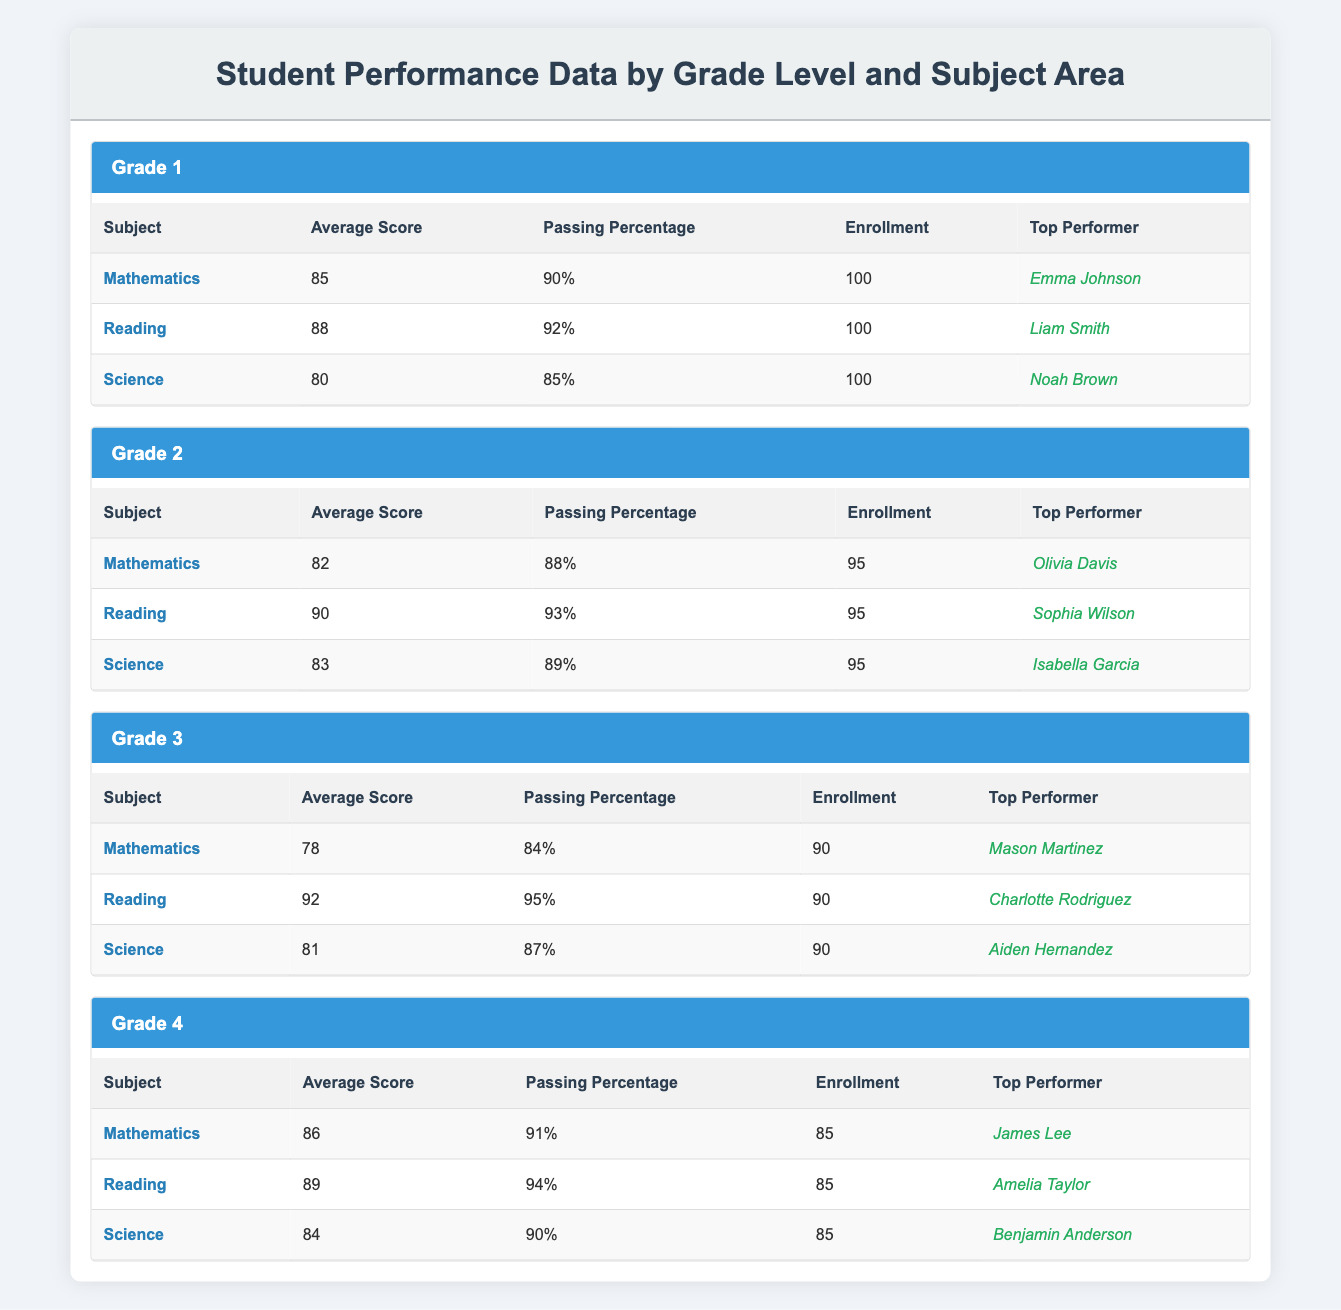What is the top performer in Mathematics for Grade 1? The table shows that the top performer in Mathematics for Grade 1 is Emma Johnson, as listed in the corresponding row.
Answer: Emma Johnson What is the average score in Reading for Grade 3? The table indicates that the average score in Reading for Grade 3 is 92, found in the respective row under the Reading column for Grade 3.
Answer: 92 Which grade has the highest average score in Science? The average scores for Science across grades are: Grade 1: 80, Grade 2: 83, Grade 3: 81, and Grade 4: 84. Comparing these values, Grade 4 has the highest average score, which is 84.
Answer: Grade 4 What is the overall passing percentage for Mathematics across all grades? The passing percentages for Mathematics are: Grade 1: 90%, Grade 2: 88%, Grade 3: 84%, and Grade 4: 91%. To find the overall passing percentage, we sum these percentages: 90 + 88 + 84 + 91 = 353, and then divide by the number of grades (4), giving us an average of 353/4 = 88.25%.
Answer: 88.25% Is there any subject where Grade 2 has a higher average score than Grade 1? In the table, the average scores for Grade 1 are Mathematics: 85, Reading: 88, and Science: 80. For Grade 2, the scores are Mathematics: 82, Reading: 90, and Science: 83. Comparing these, Grade 2 has a higher average score in Reading (90 > 88), but lower scores in Mathematics and Science. Thus, yes, Reading is the subject where Grade 2's score is higher.
Answer: Yes What is the average enrollment across all grades for Reading? The enrollment for Reading is: Grade 1: 100, Grade 2: 95, Grade 3: 90, and Grade 4: 85. To find the average, we sum these values: 100 + 95 + 90 + 85 = 370, and divide by 4 for the average, which gives us 370/4 = 92.5.
Answer: 92.5 What is the difference in passing percentages for Science between Grade 3 and Grade 4? The passing percentage for Science in Grade 3 is 87% and in Grade 4 it is 90%. To find the difference, we subtract the smaller percentage from the larger one: 90 - 87 = 3.
Answer: 3 Which subject has the lowest passing percentage in Grade 1? The passing percentages for Grade 1 subjects are Mathematics: 90%, Reading: 92%, and Science: 85%. The lowest is Science with a passing percentage of 85.
Answer: Science What is the top-performing grade in Reading based on average score? The average scores for Reading are: Grade 1: 88, Grade 2: 90, Grade 3: 92, and Grade 4: 89. The highest score is for Grade 3 at 92.
Answer: Grade 3 